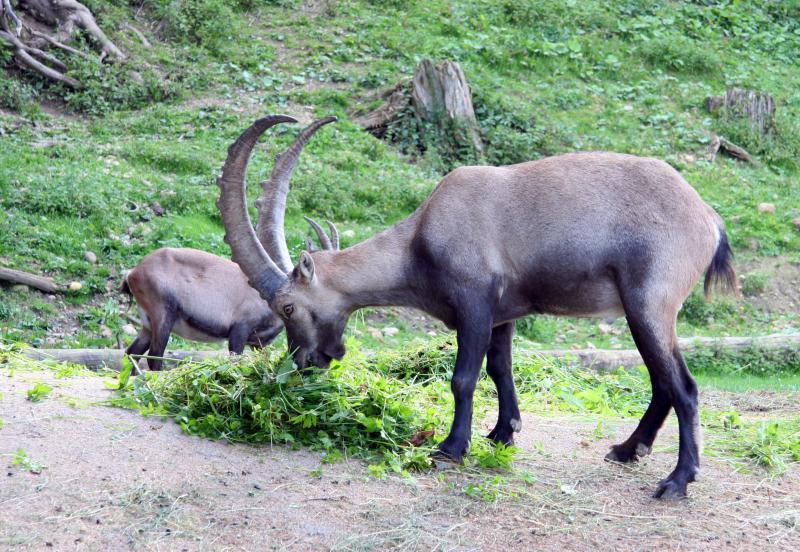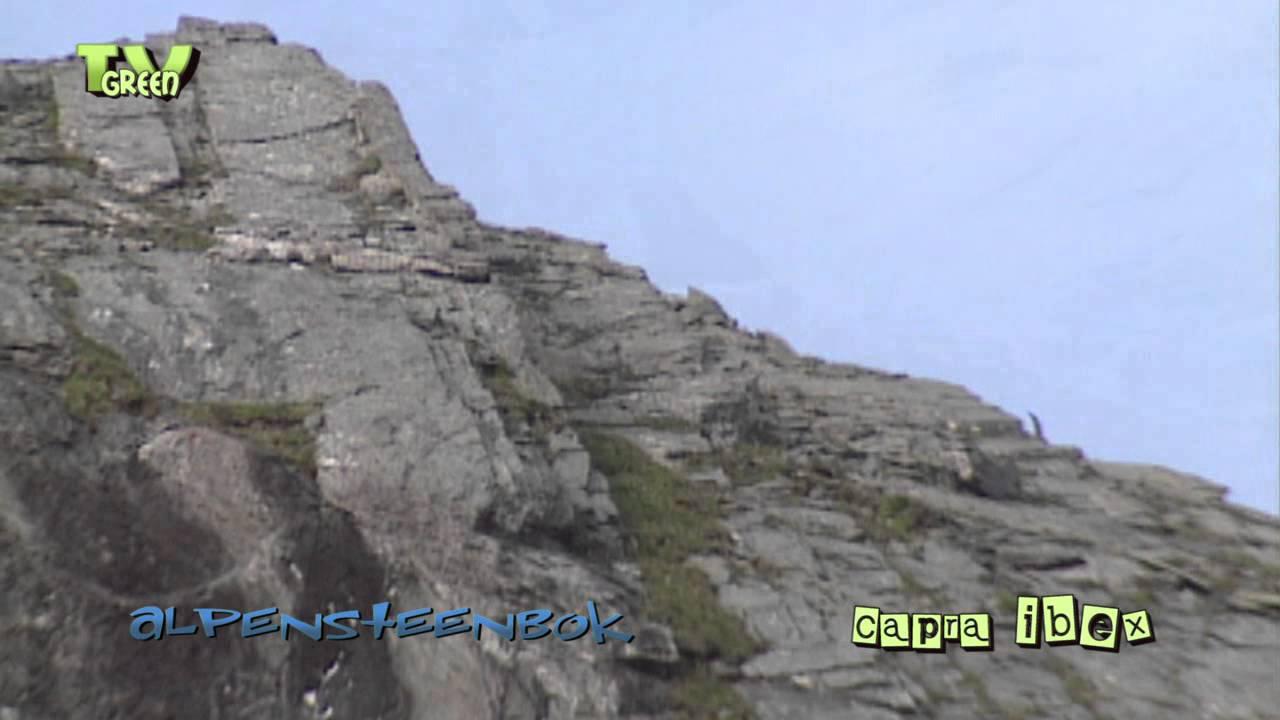The first image is the image on the left, the second image is the image on the right. Examine the images to the left and right. Is the description "There are at least two animals in the image on the left." accurate? Answer yes or no. Yes. 